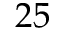<formula> <loc_0><loc_0><loc_500><loc_500>2 5</formula> 